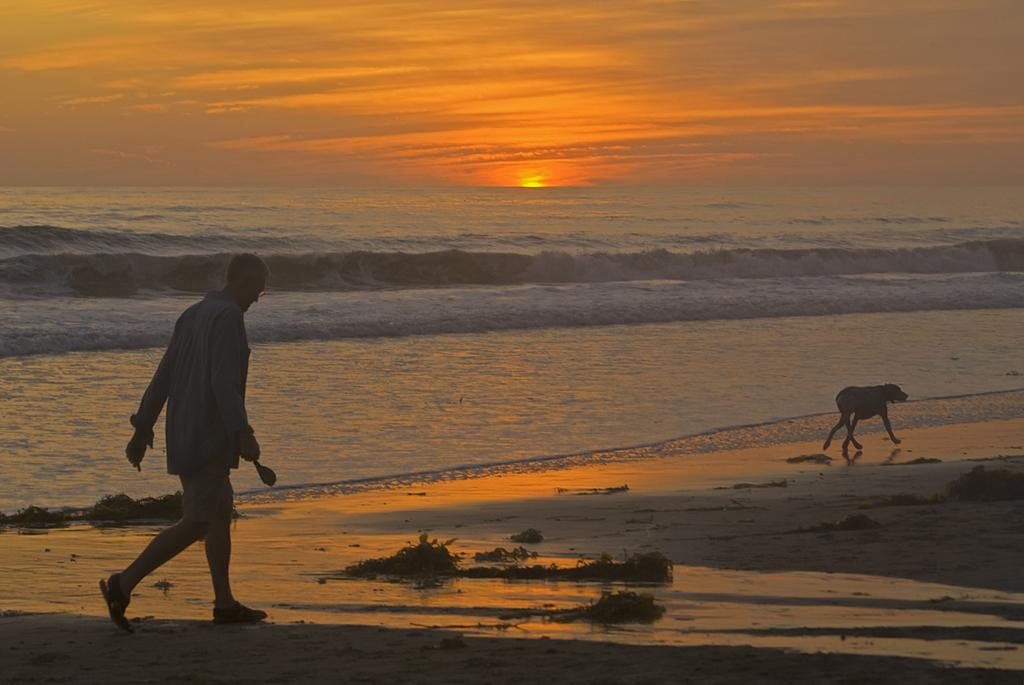Who is present in the image? There is a man in the image. What other living creature is present in the image? There is a dog in the image. What are the man and dog doing in the image? The man and dog are walking. What is the man holding in the image? The man is holding an object. What natural elements can be seen in the image? Water and sky are visible in the image. How many cats are visible in the image? There are no cats present in the image. What type of mint can be seen growing near the water in the image? There is no mint visible in the image, and the image does not show any plants growing near the water. 